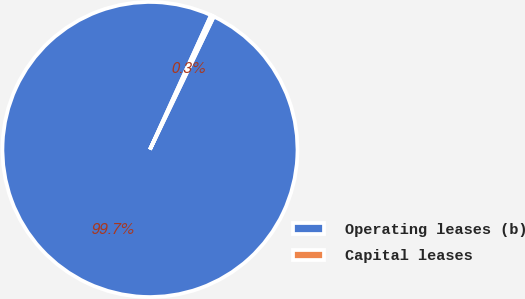Convert chart to OTSL. <chart><loc_0><loc_0><loc_500><loc_500><pie_chart><fcel>Operating leases (b)<fcel>Capital leases<nl><fcel>99.66%<fcel>0.34%<nl></chart> 